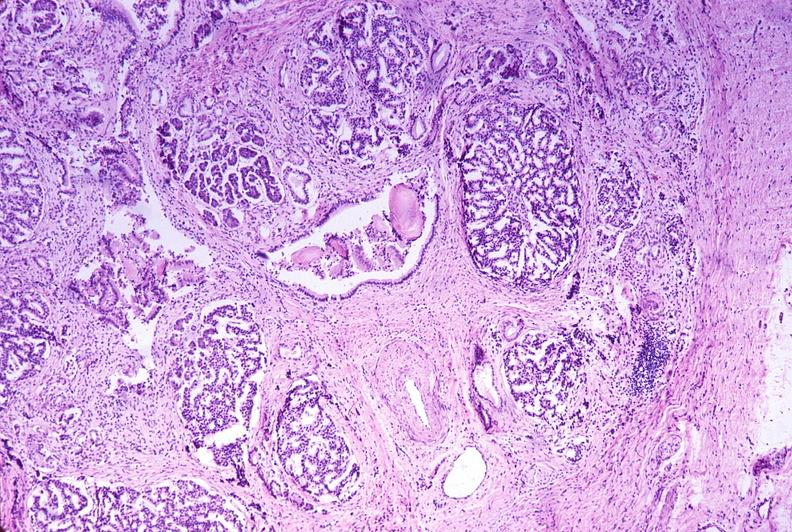does this image show chronic pancreatitis?
Answer the question using a single word or phrase. Yes 